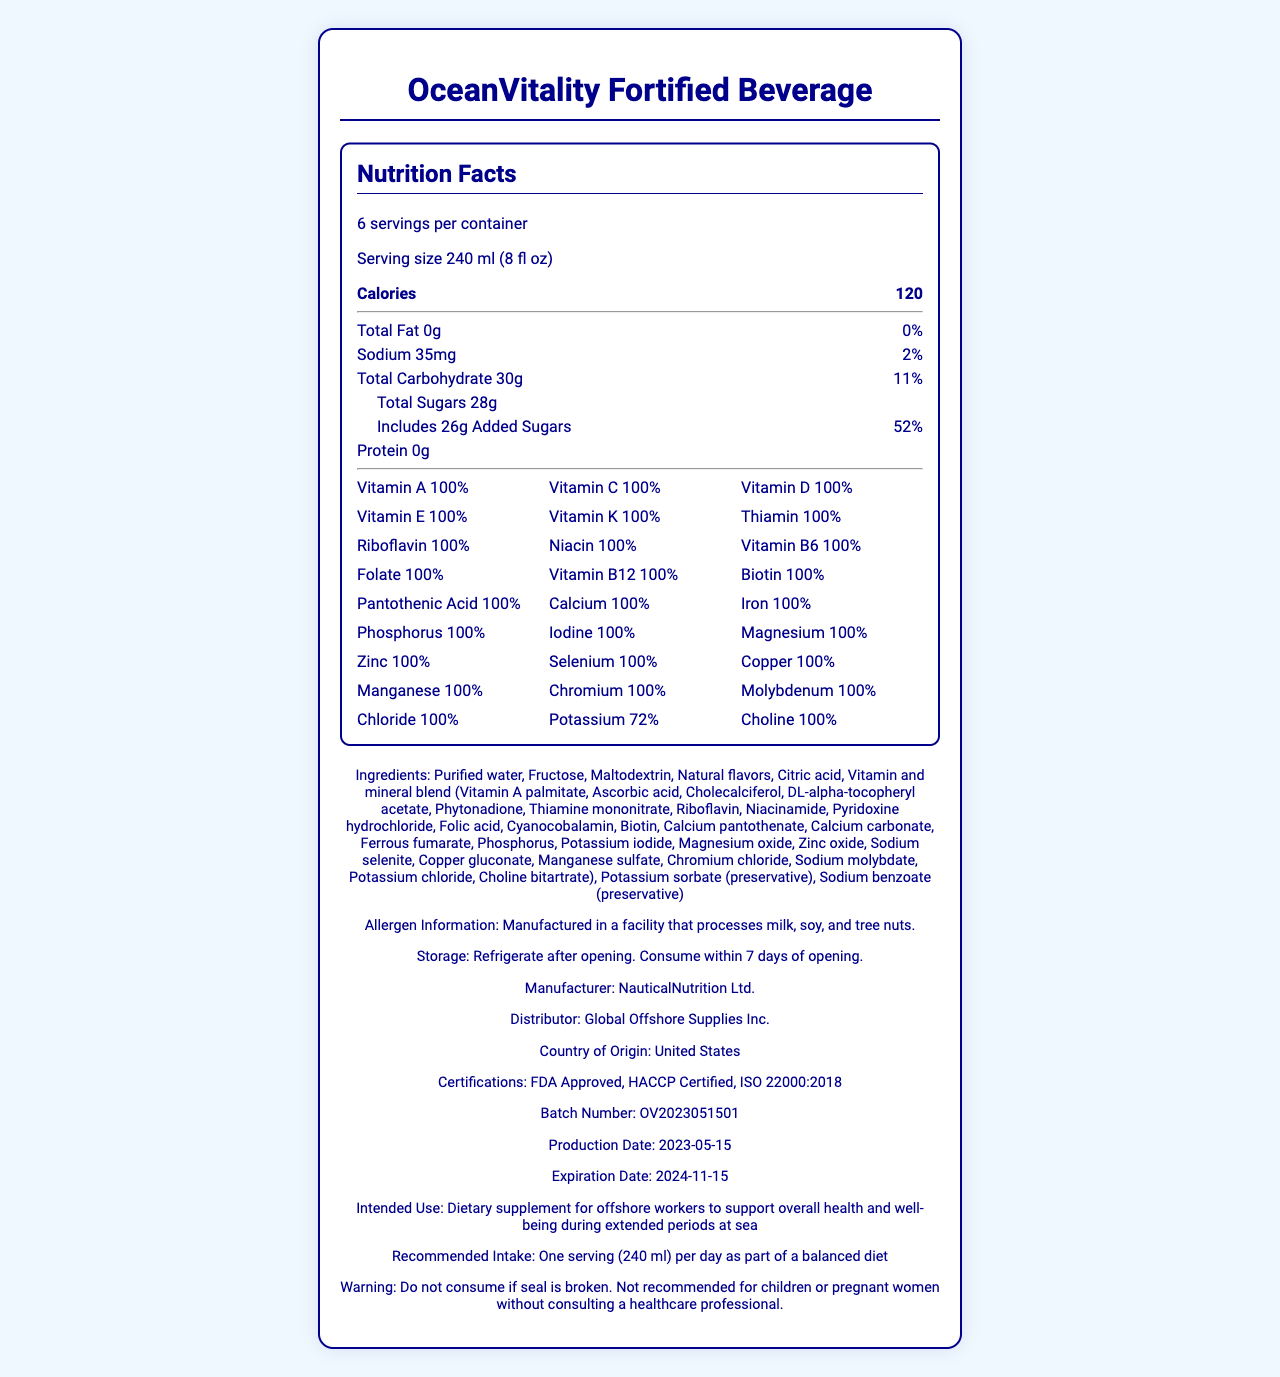what is the product name? The product name is clearly stated as "OceanVitality Fortified Beverage" at the top of the document.
Answer: OceanVitality Fortified Beverage what is the serving size? The serving size is specified as "240 ml (8 fl oz)" in the document.
Answer: 240 ml (8 fl oz) how many servings are per container? The document states there are "6 servings per container".
Answer: 6 how many calories does one serving have? One serving contains 120 calories, as indicated in the document.
Answer: 120 what is the total carbohydrate content per serving? The total carbohydrate content per serving is listed as 30g in the document.
Answer: 30g what percentage of the daily value of sodium is in one serving? The sodium content in one serving is 35mg, which is 2% of the daily value.
Answer: 2% how much added sugar is in one serving? The document shows that one serving includes 26g of added sugars.
Answer: 26g what is the daily value percentage for potassium? The daily value percentage for potassium is 72%.
Answer: 72% what is the recommended intake for this product? The recommended intake is clearly mentioned as one serving (240 ml) per day as part of a balanced diet.
Answer: One serving (240 ml) per day as part of a balanced diet is this product suitable for pregnant women without consulting a healthcare professional? The warning section states that it is not recommended for children or pregnant women without consulting a healthcare professional.
Answer: No which vitamins provide 100% of the daily value per serving? A. Vitamin A, Vitamin C, Vitamin D B. Vitamin B6, Vitamin E, Vitamin K C. All of the above The document lists Vitamin A, C, D, E, K, B6, and several other vitamins as providing 100% of the daily value per serving.
Answer: C what are the preservatives used in this beverage? A. Sodium chloride and Citric acid B. Potassium sorbate and Sodium benzoate C. Vinegar and Lemon juice The ingredients list includes "Potassium sorbate (preservative)" and "Sodium benzoate (preservative)".
Answer: B how long is the shelf life of the product when unopened? The document states that the shelf life is 18 months when unopened.
Answer: 18 months what allergens are processed in the facility that manufactures this beverage? The allergen information mentions that the facility processes milk, soy, and tree nuts.
Answer: Milk, soy, and tree nuts what is the intended use of this product? The intended use is detailed as a dietary supplement for offshore workers to support overall health and well-being during extended periods at sea.
Answer: Dietary supplement for offshore workers to support overall health and well-being during extended periods at sea what is the production date of the product? The production date listed is 2023-05-15.
Answer: 2023-05-15 what is the percentage of the daily value of iron provided by this beverage? The document shows that the beverage provides 100% of the daily value of iron.
Answer: 100% are there any allergens contained in the product itself? The document provides allergen information for the manufacturing facility but does not specifically state allergens contained within the product itself.
Answer: Cannot be determined what certifications does this product have? The document lists FDA Approval, HACCP Certification, and ISO 22000:2018 certification.
Answer: FDA Approved, HACCP Certified, ISO 22000:2018 what is the main idea of the document? This document's main idea is to present comprehensive information about the "OceanVitality Fortified Beverage," including its nutritional content, intended use, ingredients, storage instructions, and certifications.
Answer: The document provides detailed nutritional information, ingredients, allergen information, and usage guidelines for "OceanVitality Fortified Beverage," a dietary supplement designed for offshore workers. 